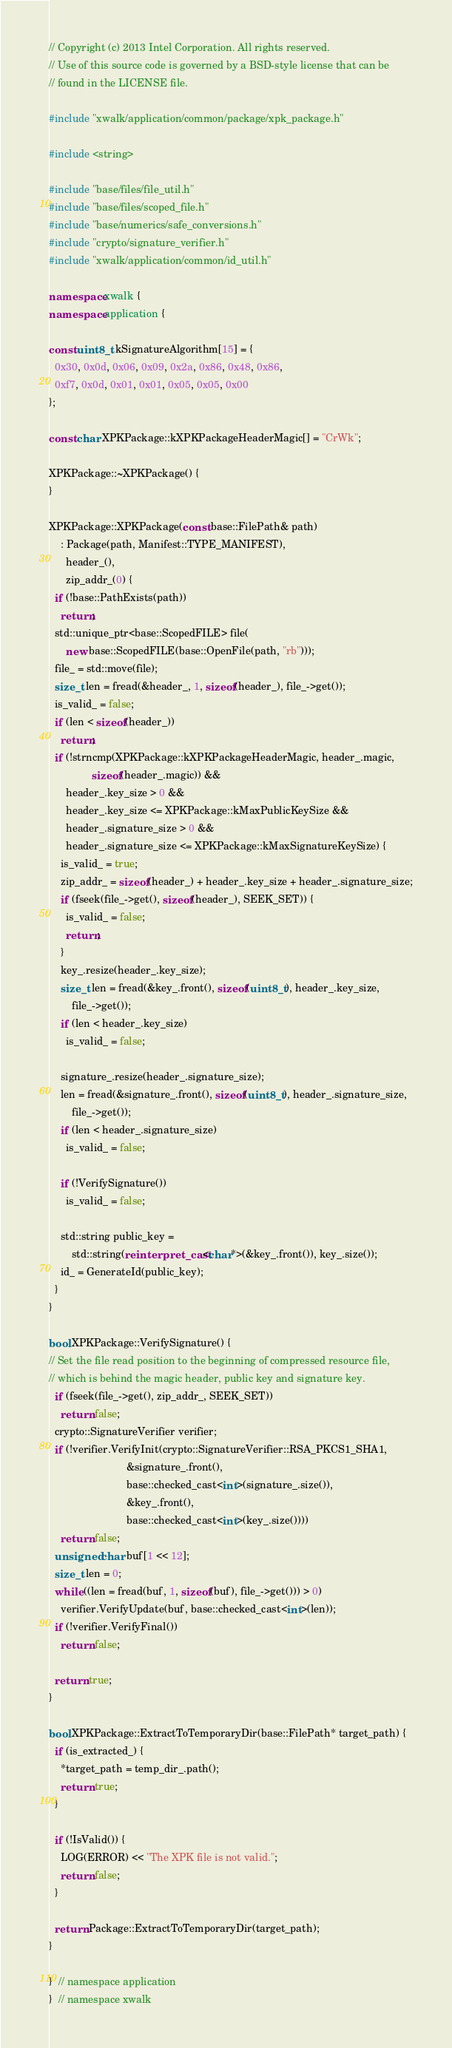<code> <loc_0><loc_0><loc_500><loc_500><_C++_>// Copyright (c) 2013 Intel Corporation. All rights reserved.
// Use of this source code is governed by a BSD-style license that can be
// found in the LICENSE file.

#include "xwalk/application/common/package/xpk_package.h"

#include <string>

#include "base/files/file_util.h"
#include "base/files/scoped_file.h"
#include "base/numerics/safe_conversions.h"
#include "crypto/signature_verifier.h"
#include "xwalk/application/common/id_util.h"

namespace xwalk {
namespace application {

const uint8_t kSignatureAlgorithm[15] = {
  0x30, 0x0d, 0x06, 0x09, 0x2a, 0x86, 0x48, 0x86,
  0xf7, 0x0d, 0x01, 0x01, 0x05, 0x05, 0x00
};

const char XPKPackage::kXPKPackageHeaderMagic[] = "CrWk";

XPKPackage::~XPKPackage() {
}

XPKPackage::XPKPackage(const base::FilePath& path)
    : Package(path, Manifest::TYPE_MANIFEST),
      header_(),
      zip_addr_(0) {
  if (!base::PathExists(path))
    return;
  std::unique_ptr<base::ScopedFILE> file(
      new base::ScopedFILE(base::OpenFile(path, "rb")));
  file_ = std::move(file);
  size_t len = fread(&header_, 1, sizeof(header_), file_->get());
  is_valid_ = false;
  if (len < sizeof(header_))
    return;
  if (!strncmp(XPKPackage::kXPKPackageHeaderMagic, header_.magic,
               sizeof(header_.magic)) &&
      header_.key_size > 0 &&
      header_.key_size <= XPKPackage::kMaxPublicKeySize &&
      header_.signature_size > 0 &&
      header_.signature_size <= XPKPackage::kMaxSignatureKeySize) {
    is_valid_ = true;
    zip_addr_ = sizeof(header_) + header_.key_size + header_.signature_size;
    if (fseek(file_->get(), sizeof(header_), SEEK_SET)) {
      is_valid_ = false;
      return;
    }
    key_.resize(header_.key_size);
    size_t len = fread(&key_.front(), sizeof(uint8_t), header_.key_size,
        file_->get());
    if (len < header_.key_size)
      is_valid_ = false;

    signature_.resize(header_.signature_size);
    len = fread(&signature_.front(), sizeof(uint8_t), header_.signature_size,
        file_->get());
    if (len < header_.signature_size)
      is_valid_ = false;

    if (!VerifySignature())
      is_valid_ = false;

    std::string public_key =
        std::string(reinterpret_cast<char*>(&key_.front()), key_.size());
    id_ = GenerateId(public_key);
  }
}

bool XPKPackage::VerifySignature() {
// Set the file read position to the beginning of compressed resource file,
// which is behind the magic header, public key and signature key.
  if (fseek(file_->get(), zip_addr_, SEEK_SET))
    return false;
  crypto::SignatureVerifier verifier;
  if (!verifier.VerifyInit(crypto::SignatureVerifier::RSA_PKCS1_SHA1,
                           &signature_.front(),
                           base::checked_cast<int>(signature_.size()),
                           &key_.front(),
                           base::checked_cast<int>(key_.size())))
    return false;
  unsigned char buf[1 << 12];
  size_t len = 0;
  while ((len = fread(buf, 1, sizeof(buf), file_->get())) > 0)
    verifier.VerifyUpdate(buf, base::checked_cast<int>(len));
  if (!verifier.VerifyFinal())
    return false;

  return true;
}

bool XPKPackage::ExtractToTemporaryDir(base::FilePath* target_path) {
  if (is_extracted_) {
    *target_path = temp_dir_.path();
    return true;
  }

  if (!IsValid()) {
    LOG(ERROR) << "The XPK file is not valid.";
    return false;
  }

  return Package::ExtractToTemporaryDir(target_path);
}

}  // namespace application
}  // namespace xwalk
</code> 